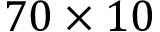Convert formula to latex. <formula><loc_0><loc_0><loc_500><loc_500>7 0 \times 1 0</formula> 